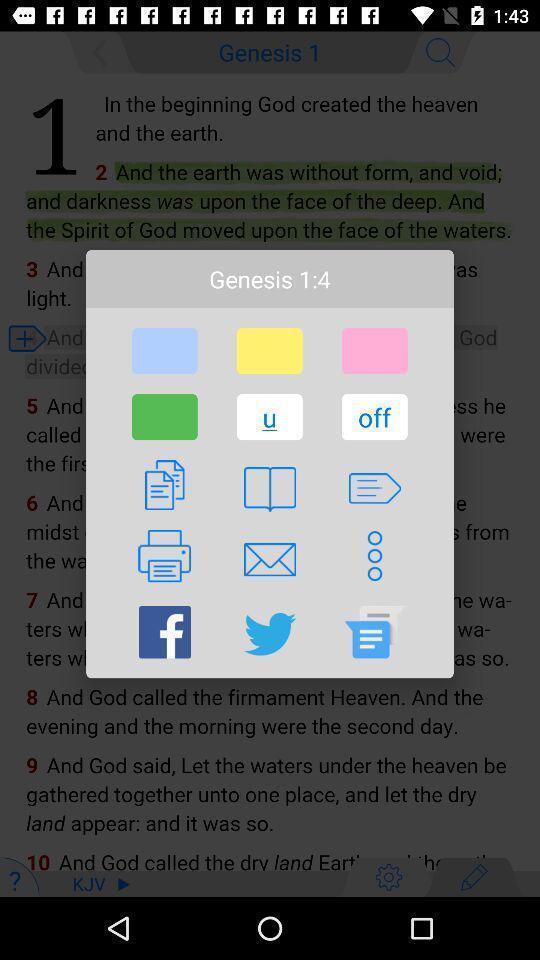Give me a summary of this screen capture. Pop up to share article through various applications. 